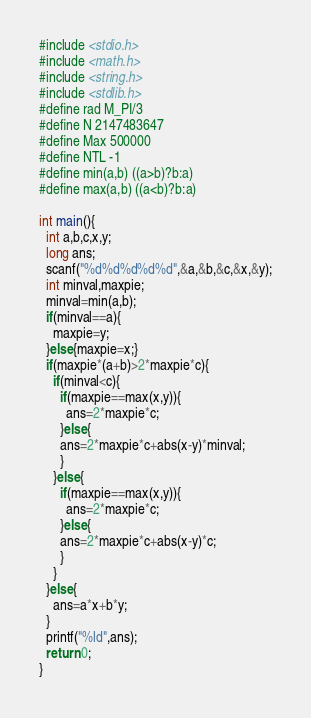<code> <loc_0><loc_0><loc_500><loc_500><_C_>#include <stdio.h>
#include <math.h>
#include <string.h>
#include <stdlib.h>
#define rad M_PI/3
#define N 2147483647
#define Max 500000
#define NTL -1
#define min(a,b) ((a>b)?b:a)
#define max(a,b) ((a<b)?b:a)

int main(){
  int a,b,c,x,y;
  long ans;
  scanf("%d%d%d%d%d",&a,&b,&c,&x,&y);
  int minval,maxpie;
  minval=min(a,b);
  if(minval==a){
    maxpie=y;
  }else{maxpie=x;}
  if(maxpie*(a+b)>2*maxpie*c){
    if(minval<c){
      if(maxpie==max(x,y)){
        ans=2*maxpie*c;
      }else{
      ans=2*maxpie*c+abs(x-y)*minval;
      }
    }else{
      if(maxpie==max(x,y)){
        ans=2*maxpie*c;
      }else{
      ans=2*maxpie*c+abs(x-y)*c;
      }
    }
  }else{
    ans=a*x+b*y;
  }
  printf("%ld",ans);
  return 0;
}</code> 